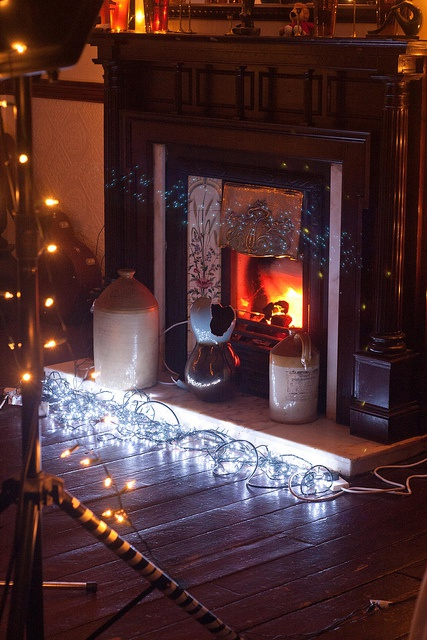Describe the objects in this image and their specific colors. I can see a vase in maroon, black, and purple tones in this image. 